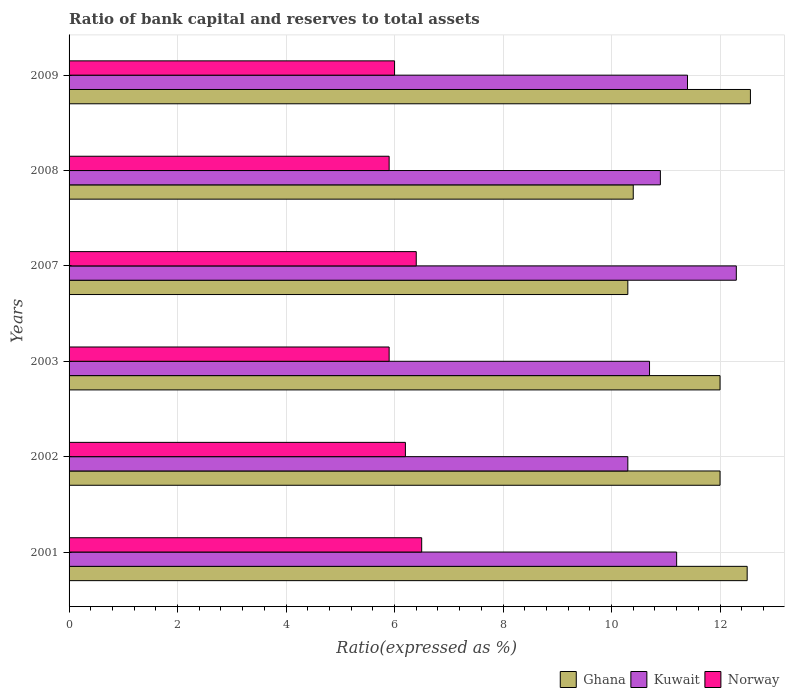How many groups of bars are there?
Provide a short and direct response. 6. In how many cases, is the number of bars for a given year not equal to the number of legend labels?
Offer a terse response. 0. What is the ratio of bank capital and reserves to total assets in Kuwait in 2002?
Provide a succinct answer. 10.3. Across all years, what is the maximum ratio of bank capital and reserves to total assets in Kuwait?
Your answer should be compact. 12.3. Across all years, what is the minimum ratio of bank capital and reserves to total assets in Kuwait?
Keep it short and to the point. 10.3. In which year was the ratio of bank capital and reserves to total assets in Kuwait maximum?
Provide a succinct answer. 2007. In which year was the ratio of bank capital and reserves to total assets in Norway minimum?
Provide a short and direct response. 2003. What is the total ratio of bank capital and reserves to total assets in Norway in the graph?
Offer a terse response. 36.9. What is the difference between the ratio of bank capital and reserves to total assets in Norway in 2007 and that in 2008?
Provide a short and direct response. 0.5. What is the difference between the ratio of bank capital and reserves to total assets in Kuwait in 2003 and the ratio of bank capital and reserves to total assets in Norway in 2002?
Keep it short and to the point. 4.5. What is the average ratio of bank capital and reserves to total assets in Kuwait per year?
Provide a succinct answer. 11.13. In the year 2009, what is the difference between the ratio of bank capital and reserves to total assets in Norway and ratio of bank capital and reserves to total assets in Ghana?
Provide a succinct answer. -6.56. What is the ratio of the ratio of bank capital and reserves to total assets in Kuwait in 2002 to that in 2003?
Keep it short and to the point. 0.96. Is the ratio of bank capital and reserves to total assets in Kuwait in 2001 less than that in 2009?
Ensure brevity in your answer.  Yes. What is the difference between the highest and the second highest ratio of bank capital and reserves to total assets in Norway?
Offer a very short reply. 0.1. What is the difference between the highest and the lowest ratio of bank capital and reserves to total assets in Norway?
Provide a succinct answer. 0.6. Is the sum of the ratio of bank capital and reserves to total assets in Norway in 2007 and 2008 greater than the maximum ratio of bank capital and reserves to total assets in Kuwait across all years?
Your answer should be compact. No. What does the 2nd bar from the top in 2007 represents?
Ensure brevity in your answer.  Kuwait. Is it the case that in every year, the sum of the ratio of bank capital and reserves to total assets in Norway and ratio of bank capital and reserves to total assets in Kuwait is greater than the ratio of bank capital and reserves to total assets in Ghana?
Give a very brief answer. Yes. How many bars are there?
Provide a short and direct response. 18. Does the graph contain any zero values?
Your answer should be compact. No. Does the graph contain grids?
Provide a succinct answer. Yes. How many legend labels are there?
Your answer should be very brief. 3. How are the legend labels stacked?
Ensure brevity in your answer.  Horizontal. What is the title of the graph?
Keep it short and to the point. Ratio of bank capital and reserves to total assets. What is the label or title of the X-axis?
Your answer should be very brief. Ratio(expressed as %). What is the Ratio(expressed as %) in Ghana in 2001?
Keep it short and to the point. 12.5. What is the Ratio(expressed as %) in Kuwait in 2001?
Keep it short and to the point. 11.2. What is the Ratio(expressed as %) of Ghana in 2002?
Your answer should be very brief. 12. What is the Ratio(expressed as %) of Norway in 2002?
Give a very brief answer. 6.2. What is the Ratio(expressed as %) in Ghana in 2003?
Provide a short and direct response. 12. What is the Ratio(expressed as %) in Kuwait in 2003?
Your response must be concise. 10.7. What is the Ratio(expressed as %) of Ghana in 2007?
Keep it short and to the point. 10.3. What is the Ratio(expressed as %) in Norway in 2007?
Provide a succinct answer. 6.4. What is the Ratio(expressed as %) in Kuwait in 2008?
Your response must be concise. 10.9. What is the Ratio(expressed as %) of Norway in 2008?
Offer a terse response. 5.9. What is the Ratio(expressed as %) in Ghana in 2009?
Provide a short and direct response. 12.56. What is the Ratio(expressed as %) in Norway in 2009?
Your answer should be very brief. 6. Across all years, what is the maximum Ratio(expressed as %) in Ghana?
Make the answer very short. 12.56. Across all years, what is the maximum Ratio(expressed as %) in Kuwait?
Ensure brevity in your answer.  12.3. Across all years, what is the maximum Ratio(expressed as %) of Norway?
Give a very brief answer. 6.5. Across all years, what is the minimum Ratio(expressed as %) in Norway?
Give a very brief answer. 5.9. What is the total Ratio(expressed as %) in Ghana in the graph?
Your answer should be compact. 69.76. What is the total Ratio(expressed as %) of Kuwait in the graph?
Keep it short and to the point. 66.8. What is the total Ratio(expressed as %) in Norway in the graph?
Keep it short and to the point. 36.9. What is the difference between the Ratio(expressed as %) in Ghana in 2001 and that in 2003?
Your answer should be compact. 0.5. What is the difference between the Ratio(expressed as %) in Kuwait in 2001 and that in 2003?
Provide a succinct answer. 0.5. What is the difference between the Ratio(expressed as %) of Kuwait in 2001 and that in 2008?
Your answer should be very brief. 0.3. What is the difference between the Ratio(expressed as %) in Norway in 2001 and that in 2008?
Give a very brief answer. 0.6. What is the difference between the Ratio(expressed as %) of Ghana in 2001 and that in 2009?
Provide a succinct answer. -0.06. What is the difference between the Ratio(expressed as %) in Ghana in 2002 and that in 2003?
Ensure brevity in your answer.  0. What is the difference between the Ratio(expressed as %) of Norway in 2002 and that in 2003?
Make the answer very short. 0.3. What is the difference between the Ratio(expressed as %) in Kuwait in 2002 and that in 2007?
Ensure brevity in your answer.  -2. What is the difference between the Ratio(expressed as %) of Ghana in 2002 and that in 2008?
Your answer should be very brief. 1.6. What is the difference between the Ratio(expressed as %) of Kuwait in 2002 and that in 2008?
Your answer should be very brief. -0.6. What is the difference between the Ratio(expressed as %) in Norway in 2002 and that in 2008?
Offer a terse response. 0.3. What is the difference between the Ratio(expressed as %) in Ghana in 2002 and that in 2009?
Provide a short and direct response. -0.56. What is the difference between the Ratio(expressed as %) in Kuwait in 2002 and that in 2009?
Your answer should be very brief. -1.1. What is the difference between the Ratio(expressed as %) of Norway in 2002 and that in 2009?
Offer a very short reply. 0.2. What is the difference between the Ratio(expressed as %) of Kuwait in 2003 and that in 2007?
Offer a terse response. -1.6. What is the difference between the Ratio(expressed as %) in Norway in 2003 and that in 2008?
Your answer should be very brief. 0. What is the difference between the Ratio(expressed as %) of Ghana in 2003 and that in 2009?
Ensure brevity in your answer.  -0.56. What is the difference between the Ratio(expressed as %) of Kuwait in 2003 and that in 2009?
Give a very brief answer. -0.7. What is the difference between the Ratio(expressed as %) in Norway in 2007 and that in 2008?
Provide a short and direct response. 0.5. What is the difference between the Ratio(expressed as %) of Ghana in 2007 and that in 2009?
Provide a succinct answer. -2.26. What is the difference between the Ratio(expressed as %) of Kuwait in 2007 and that in 2009?
Your answer should be very brief. 0.9. What is the difference between the Ratio(expressed as %) of Norway in 2007 and that in 2009?
Offer a very short reply. 0.4. What is the difference between the Ratio(expressed as %) in Ghana in 2008 and that in 2009?
Your response must be concise. -2.16. What is the difference between the Ratio(expressed as %) in Kuwait in 2008 and that in 2009?
Offer a terse response. -0.5. What is the difference between the Ratio(expressed as %) in Norway in 2008 and that in 2009?
Offer a terse response. -0.1. What is the difference between the Ratio(expressed as %) of Ghana in 2001 and the Ratio(expressed as %) of Kuwait in 2002?
Your answer should be very brief. 2.2. What is the difference between the Ratio(expressed as %) of Ghana in 2001 and the Ratio(expressed as %) of Norway in 2002?
Your answer should be compact. 6.3. What is the difference between the Ratio(expressed as %) in Kuwait in 2001 and the Ratio(expressed as %) in Norway in 2008?
Offer a terse response. 5.3. What is the difference between the Ratio(expressed as %) in Ghana in 2001 and the Ratio(expressed as %) in Norway in 2009?
Keep it short and to the point. 6.5. What is the difference between the Ratio(expressed as %) in Ghana in 2002 and the Ratio(expressed as %) in Kuwait in 2003?
Your answer should be compact. 1.3. What is the difference between the Ratio(expressed as %) of Ghana in 2002 and the Ratio(expressed as %) of Norway in 2003?
Make the answer very short. 6.1. What is the difference between the Ratio(expressed as %) of Kuwait in 2002 and the Ratio(expressed as %) of Norway in 2003?
Give a very brief answer. 4.4. What is the difference between the Ratio(expressed as %) of Ghana in 2002 and the Ratio(expressed as %) of Norway in 2008?
Make the answer very short. 6.1. What is the difference between the Ratio(expressed as %) of Kuwait in 2002 and the Ratio(expressed as %) of Norway in 2008?
Keep it short and to the point. 4.4. What is the difference between the Ratio(expressed as %) of Ghana in 2003 and the Ratio(expressed as %) of Norway in 2007?
Your answer should be very brief. 5.6. What is the difference between the Ratio(expressed as %) of Kuwait in 2003 and the Ratio(expressed as %) of Norway in 2007?
Provide a short and direct response. 4.3. What is the difference between the Ratio(expressed as %) in Ghana in 2003 and the Ratio(expressed as %) in Kuwait in 2009?
Your answer should be very brief. 0.6. What is the difference between the Ratio(expressed as %) in Ghana in 2003 and the Ratio(expressed as %) in Norway in 2009?
Give a very brief answer. 6. What is the difference between the Ratio(expressed as %) of Kuwait in 2003 and the Ratio(expressed as %) of Norway in 2009?
Provide a short and direct response. 4.7. What is the difference between the Ratio(expressed as %) of Ghana in 2007 and the Ratio(expressed as %) of Norway in 2008?
Ensure brevity in your answer.  4.4. What is the difference between the Ratio(expressed as %) in Kuwait in 2007 and the Ratio(expressed as %) in Norway in 2008?
Provide a short and direct response. 6.4. What is the difference between the Ratio(expressed as %) in Ghana in 2007 and the Ratio(expressed as %) in Norway in 2009?
Your response must be concise. 4.3. What is the difference between the Ratio(expressed as %) in Kuwait in 2007 and the Ratio(expressed as %) in Norway in 2009?
Make the answer very short. 6.3. What is the difference between the Ratio(expressed as %) of Ghana in 2008 and the Ratio(expressed as %) of Kuwait in 2009?
Offer a terse response. -1. What is the difference between the Ratio(expressed as %) of Ghana in 2008 and the Ratio(expressed as %) of Norway in 2009?
Ensure brevity in your answer.  4.4. What is the average Ratio(expressed as %) of Ghana per year?
Your response must be concise. 11.63. What is the average Ratio(expressed as %) in Kuwait per year?
Your answer should be very brief. 11.13. What is the average Ratio(expressed as %) in Norway per year?
Your answer should be very brief. 6.15. In the year 2001, what is the difference between the Ratio(expressed as %) of Ghana and Ratio(expressed as %) of Kuwait?
Your response must be concise. 1.3. In the year 2001, what is the difference between the Ratio(expressed as %) of Ghana and Ratio(expressed as %) of Norway?
Give a very brief answer. 6. In the year 2003, what is the difference between the Ratio(expressed as %) of Ghana and Ratio(expressed as %) of Kuwait?
Provide a succinct answer. 1.3. In the year 2003, what is the difference between the Ratio(expressed as %) in Ghana and Ratio(expressed as %) in Norway?
Your answer should be compact. 6.1. In the year 2007, what is the difference between the Ratio(expressed as %) in Kuwait and Ratio(expressed as %) in Norway?
Your response must be concise. 5.9. In the year 2008, what is the difference between the Ratio(expressed as %) in Ghana and Ratio(expressed as %) in Kuwait?
Your response must be concise. -0.5. In the year 2008, what is the difference between the Ratio(expressed as %) of Ghana and Ratio(expressed as %) of Norway?
Offer a terse response. 4.5. In the year 2009, what is the difference between the Ratio(expressed as %) in Ghana and Ratio(expressed as %) in Kuwait?
Make the answer very short. 1.16. In the year 2009, what is the difference between the Ratio(expressed as %) of Ghana and Ratio(expressed as %) of Norway?
Make the answer very short. 6.56. In the year 2009, what is the difference between the Ratio(expressed as %) of Kuwait and Ratio(expressed as %) of Norway?
Offer a very short reply. 5.4. What is the ratio of the Ratio(expressed as %) of Ghana in 2001 to that in 2002?
Your answer should be compact. 1.04. What is the ratio of the Ratio(expressed as %) of Kuwait in 2001 to that in 2002?
Ensure brevity in your answer.  1.09. What is the ratio of the Ratio(expressed as %) in Norway in 2001 to that in 2002?
Ensure brevity in your answer.  1.05. What is the ratio of the Ratio(expressed as %) in Ghana in 2001 to that in 2003?
Your answer should be very brief. 1.04. What is the ratio of the Ratio(expressed as %) of Kuwait in 2001 to that in 2003?
Make the answer very short. 1.05. What is the ratio of the Ratio(expressed as %) of Norway in 2001 to that in 2003?
Give a very brief answer. 1.1. What is the ratio of the Ratio(expressed as %) in Ghana in 2001 to that in 2007?
Provide a short and direct response. 1.21. What is the ratio of the Ratio(expressed as %) in Kuwait in 2001 to that in 2007?
Make the answer very short. 0.91. What is the ratio of the Ratio(expressed as %) of Norway in 2001 to that in 2007?
Offer a terse response. 1.02. What is the ratio of the Ratio(expressed as %) in Ghana in 2001 to that in 2008?
Make the answer very short. 1.2. What is the ratio of the Ratio(expressed as %) in Kuwait in 2001 to that in 2008?
Ensure brevity in your answer.  1.03. What is the ratio of the Ratio(expressed as %) of Norway in 2001 to that in 2008?
Offer a very short reply. 1.1. What is the ratio of the Ratio(expressed as %) in Ghana in 2001 to that in 2009?
Offer a terse response. 1. What is the ratio of the Ratio(expressed as %) of Kuwait in 2001 to that in 2009?
Make the answer very short. 0.98. What is the ratio of the Ratio(expressed as %) in Norway in 2001 to that in 2009?
Offer a terse response. 1.08. What is the ratio of the Ratio(expressed as %) in Kuwait in 2002 to that in 2003?
Your answer should be compact. 0.96. What is the ratio of the Ratio(expressed as %) of Norway in 2002 to that in 2003?
Keep it short and to the point. 1.05. What is the ratio of the Ratio(expressed as %) of Ghana in 2002 to that in 2007?
Your answer should be compact. 1.17. What is the ratio of the Ratio(expressed as %) in Kuwait in 2002 to that in 2007?
Offer a very short reply. 0.84. What is the ratio of the Ratio(expressed as %) of Norway in 2002 to that in 2007?
Keep it short and to the point. 0.97. What is the ratio of the Ratio(expressed as %) of Ghana in 2002 to that in 2008?
Ensure brevity in your answer.  1.15. What is the ratio of the Ratio(expressed as %) of Kuwait in 2002 to that in 2008?
Your response must be concise. 0.94. What is the ratio of the Ratio(expressed as %) in Norway in 2002 to that in 2008?
Your answer should be very brief. 1.05. What is the ratio of the Ratio(expressed as %) of Ghana in 2002 to that in 2009?
Offer a very short reply. 0.96. What is the ratio of the Ratio(expressed as %) in Kuwait in 2002 to that in 2009?
Provide a succinct answer. 0.9. What is the ratio of the Ratio(expressed as %) of Ghana in 2003 to that in 2007?
Offer a very short reply. 1.17. What is the ratio of the Ratio(expressed as %) of Kuwait in 2003 to that in 2007?
Offer a very short reply. 0.87. What is the ratio of the Ratio(expressed as %) in Norway in 2003 to that in 2007?
Provide a short and direct response. 0.92. What is the ratio of the Ratio(expressed as %) in Ghana in 2003 to that in 2008?
Offer a terse response. 1.15. What is the ratio of the Ratio(expressed as %) of Kuwait in 2003 to that in 2008?
Offer a terse response. 0.98. What is the ratio of the Ratio(expressed as %) of Ghana in 2003 to that in 2009?
Keep it short and to the point. 0.96. What is the ratio of the Ratio(expressed as %) in Kuwait in 2003 to that in 2009?
Your answer should be compact. 0.94. What is the ratio of the Ratio(expressed as %) of Norway in 2003 to that in 2009?
Offer a very short reply. 0.98. What is the ratio of the Ratio(expressed as %) in Kuwait in 2007 to that in 2008?
Your response must be concise. 1.13. What is the ratio of the Ratio(expressed as %) of Norway in 2007 to that in 2008?
Keep it short and to the point. 1.08. What is the ratio of the Ratio(expressed as %) of Ghana in 2007 to that in 2009?
Your answer should be compact. 0.82. What is the ratio of the Ratio(expressed as %) of Kuwait in 2007 to that in 2009?
Your response must be concise. 1.08. What is the ratio of the Ratio(expressed as %) in Norway in 2007 to that in 2009?
Keep it short and to the point. 1.07. What is the ratio of the Ratio(expressed as %) of Ghana in 2008 to that in 2009?
Keep it short and to the point. 0.83. What is the ratio of the Ratio(expressed as %) in Kuwait in 2008 to that in 2009?
Your response must be concise. 0.96. What is the ratio of the Ratio(expressed as %) in Norway in 2008 to that in 2009?
Your answer should be very brief. 0.98. What is the difference between the highest and the second highest Ratio(expressed as %) in Ghana?
Ensure brevity in your answer.  0.06. What is the difference between the highest and the lowest Ratio(expressed as %) of Ghana?
Keep it short and to the point. 2.26. 